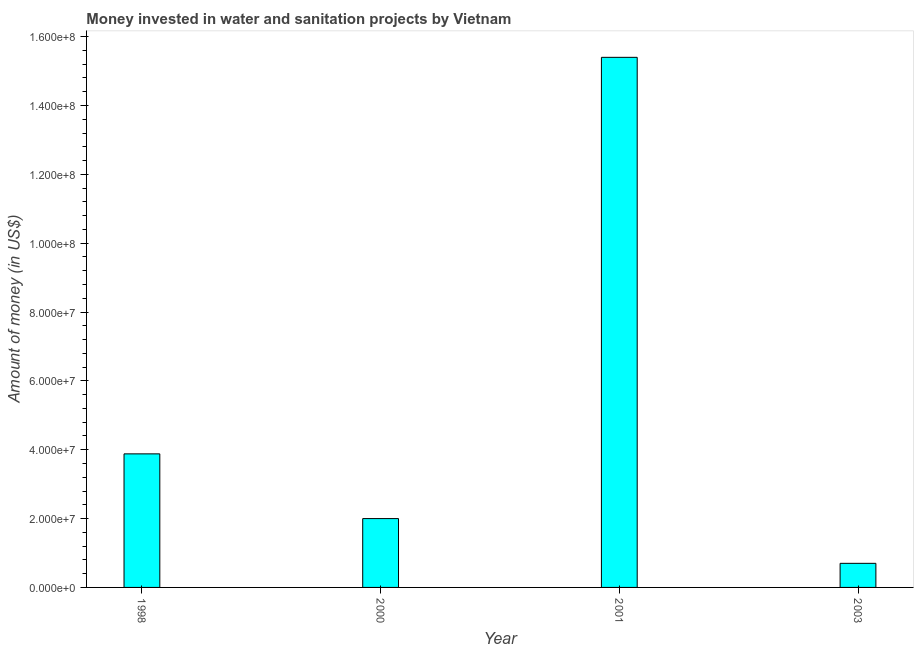Does the graph contain any zero values?
Keep it short and to the point. No. Does the graph contain grids?
Offer a terse response. No. What is the title of the graph?
Offer a terse response. Money invested in water and sanitation projects by Vietnam. What is the label or title of the X-axis?
Your answer should be compact. Year. What is the label or title of the Y-axis?
Your answer should be very brief. Amount of money (in US$). What is the investment in 2001?
Offer a very short reply. 1.54e+08. Across all years, what is the maximum investment?
Make the answer very short. 1.54e+08. In which year was the investment maximum?
Your answer should be very brief. 2001. In which year was the investment minimum?
Your response must be concise. 2003. What is the sum of the investment?
Ensure brevity in your answer.  2.20e+08. What is the difference between the investment in 2000 and 2001?
Offer a very short reply. -1.34e+08. What is the average investment per year?
Provide a short and direct response. 5.50e+07. What is the median investment?
Ensure brevity in your answer.  2.94e+07. In how many years, is the investment greater than 48000000 US$?
Provide a succinct answer. 1. Do a majority of the years between 2000 and 2001 (inclusive) have investment greater than 8000000 US$?
Keep it short and to the point. Yes. What is the ratio of the investment in 2000 to that in 2001?
Your answer should be very brief. 0.13. Is the investment in 1998 less than that in 2003?
Your response must be concise. No. What is the difference between the highest and the second highest investment?
Ensure brevity in your answer.  1.15e+08. Is the sum of the investment in 2001 and 2003 greater than the maximum investment across all years?
Give a very brief answer. Yes. What is the difference between the highest and the lowest investment?
Offer a very short reply. 1.47e+08. In how many years, is the investment greater than the average investment taken over all years?
Offer a terse response. 1. How many years are there in the graph?
Your answer should be compact. 4. What is the difference between two consecutive major ticks on the Y-axis?
Your answer should be compact. 2.00e+07. What is the Amount of money (in US$) of 1998?
Your response must be concise. 3.88e+07. What is the Amount of money (in US$) of 2001?
Your answer should be very brief. 1.54e+08. What is the Amount of money (in US$) in 2003?
Give a very brief answer. 7.00e+06. What is the difference between the Amount of money (in US$) in 1998 and 2000?
Keep it short and to the point. 1.88e+07. What is the difference between the Amount of money (in US$) in 1998 and 2001?
Your answer should be compact. -1.15e+08. What is the difference between the Amount of money (in US$) in 1998 and 2003?
Your answer should be compact. 3.18e+07. What is the difference between the Amount of money (in US$) in 2000 and 2001?
Provide a short and direct response. -1.34e+08. What is the difference between the Amount of money (in US$) in 2000 and 2003?
Provide a succinct answer. 1.30e+07. What is the difference between the Amount of money (in US$) in 2001 and 2003?
Offer a terse response. 1.47e+08. What is the ratio of the Amount of money (in US$) in 1998 to that in 2000?
Provide a succinct answer. 1.94. What is the ratio of the Amount of money (in US$) in 1998 to that in 2001?
Ensure brevity in your answer.  0.25. What is the ratio of the Amount of money (in US$) in 1998 to that in 2003?
Provide a short and direct response. 5.54. What is the ratio of the Amount of money (in US$) in 2000 to that in 2001?
Your answer should be compact. 0.13. What is the ratio of the Amount of money (in US$) in 2000 to that in 2003?
Ensure brevity in your answer.  2.86. What is the ratio of the Amount of money (in US$) in 2001 to that in 2003?
Your response must be concise. 22. 